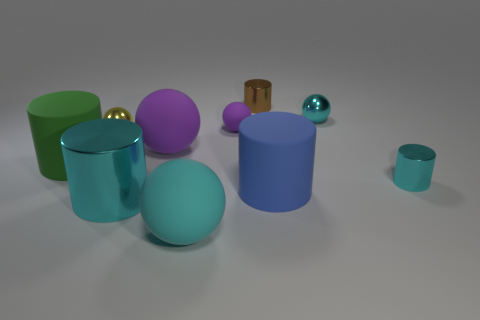Subtract 2 balls. How many balls are left? 3 Subtract all yellow balls. How many balls are left? 4 Subtract all yellow cylinders. Subtract all brown balls. How many cylinders are left? 5 Add 3 big rubber cylinders. How many big rubber cylinders are left? 5 Add 5 brown cylinders. How many brown cylinders exist? 6 Subtract 2 cyan cylinders. How many objects are left? 8 Subtract all green rubber cylinders. Subtract all big green objects. How many objects are left? 8 